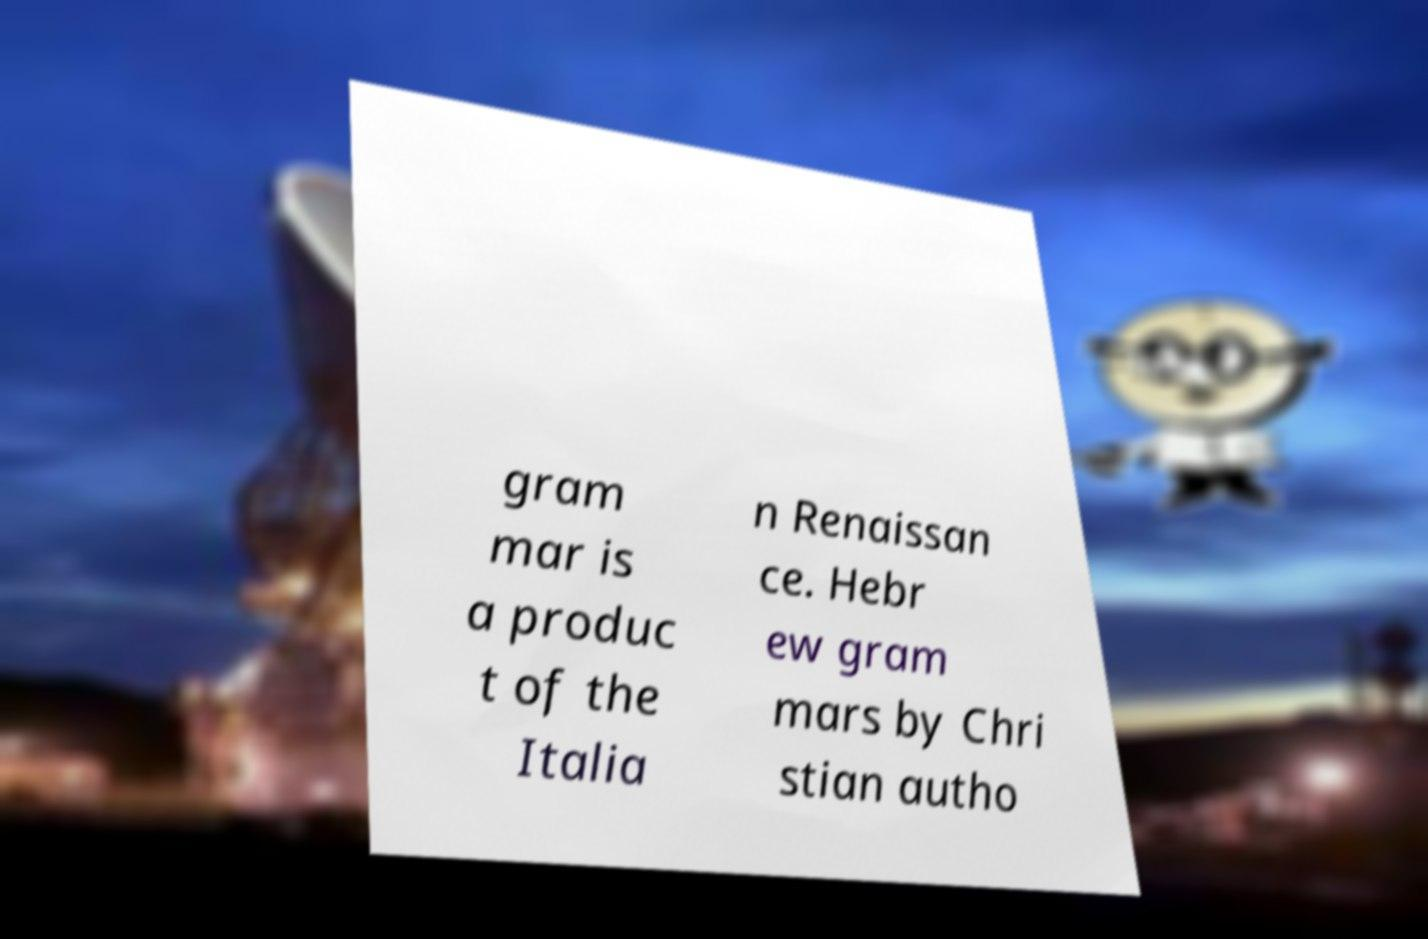There's text embedded in this image that I need extracted. Can you transcribe it verbatim? gram mar is a produc t of the Italia n Renaissan ce. Hebr ew gram mars by Chri stian autho 